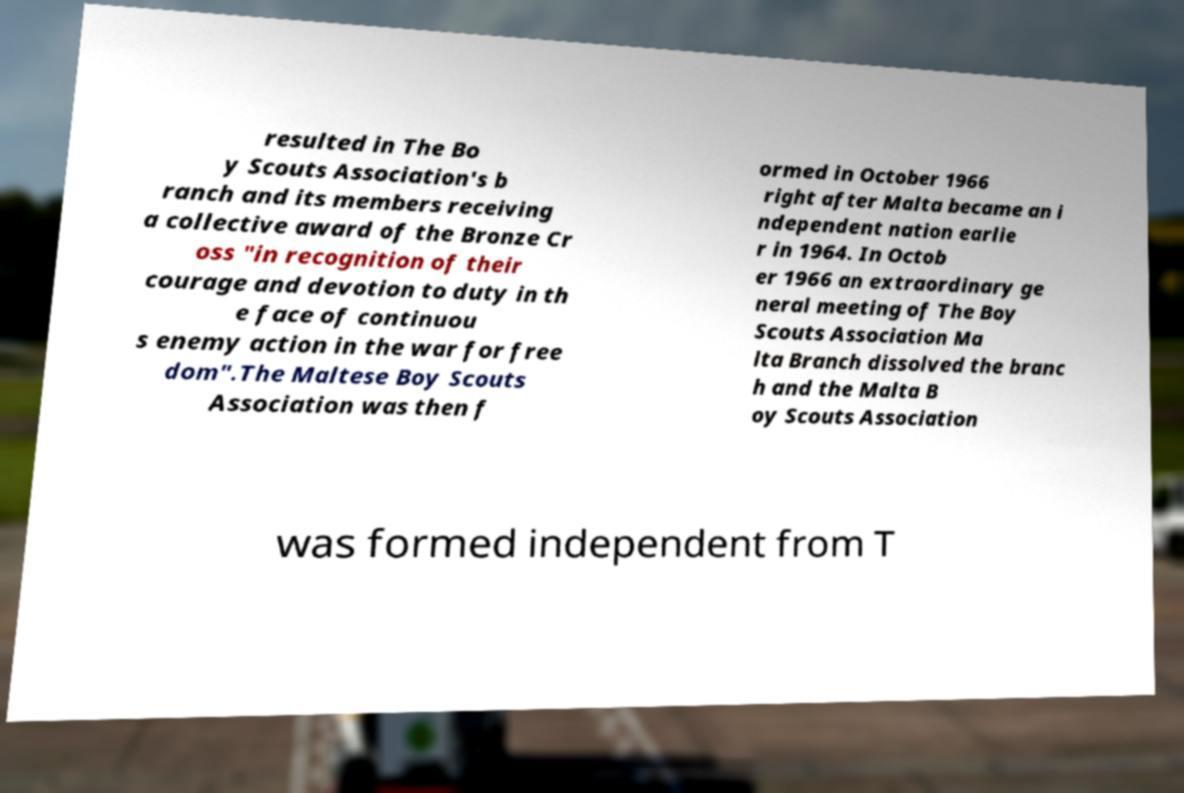There's text embedded in this image that I need extracted. Can you transcribe it verbatim? resulted in The Bo y Scouts Association's b ranch and its members receiving a collective award of the Bronze Cr oss "in recognition of their courage and devotion to duty in th e face of continuou s enemy action in the war for free dom".The Maltese Boy Scouts Association was then f ormed in October 1966 right after Malta became an i ndependent nation earlie r in 1964. In Octob er 1966 an extraordinary ge neral meeting of The Boy Scouts Association Ma lta Branch dissolved the branc h and the Malta B oy Scouts Association was formed independent from T 